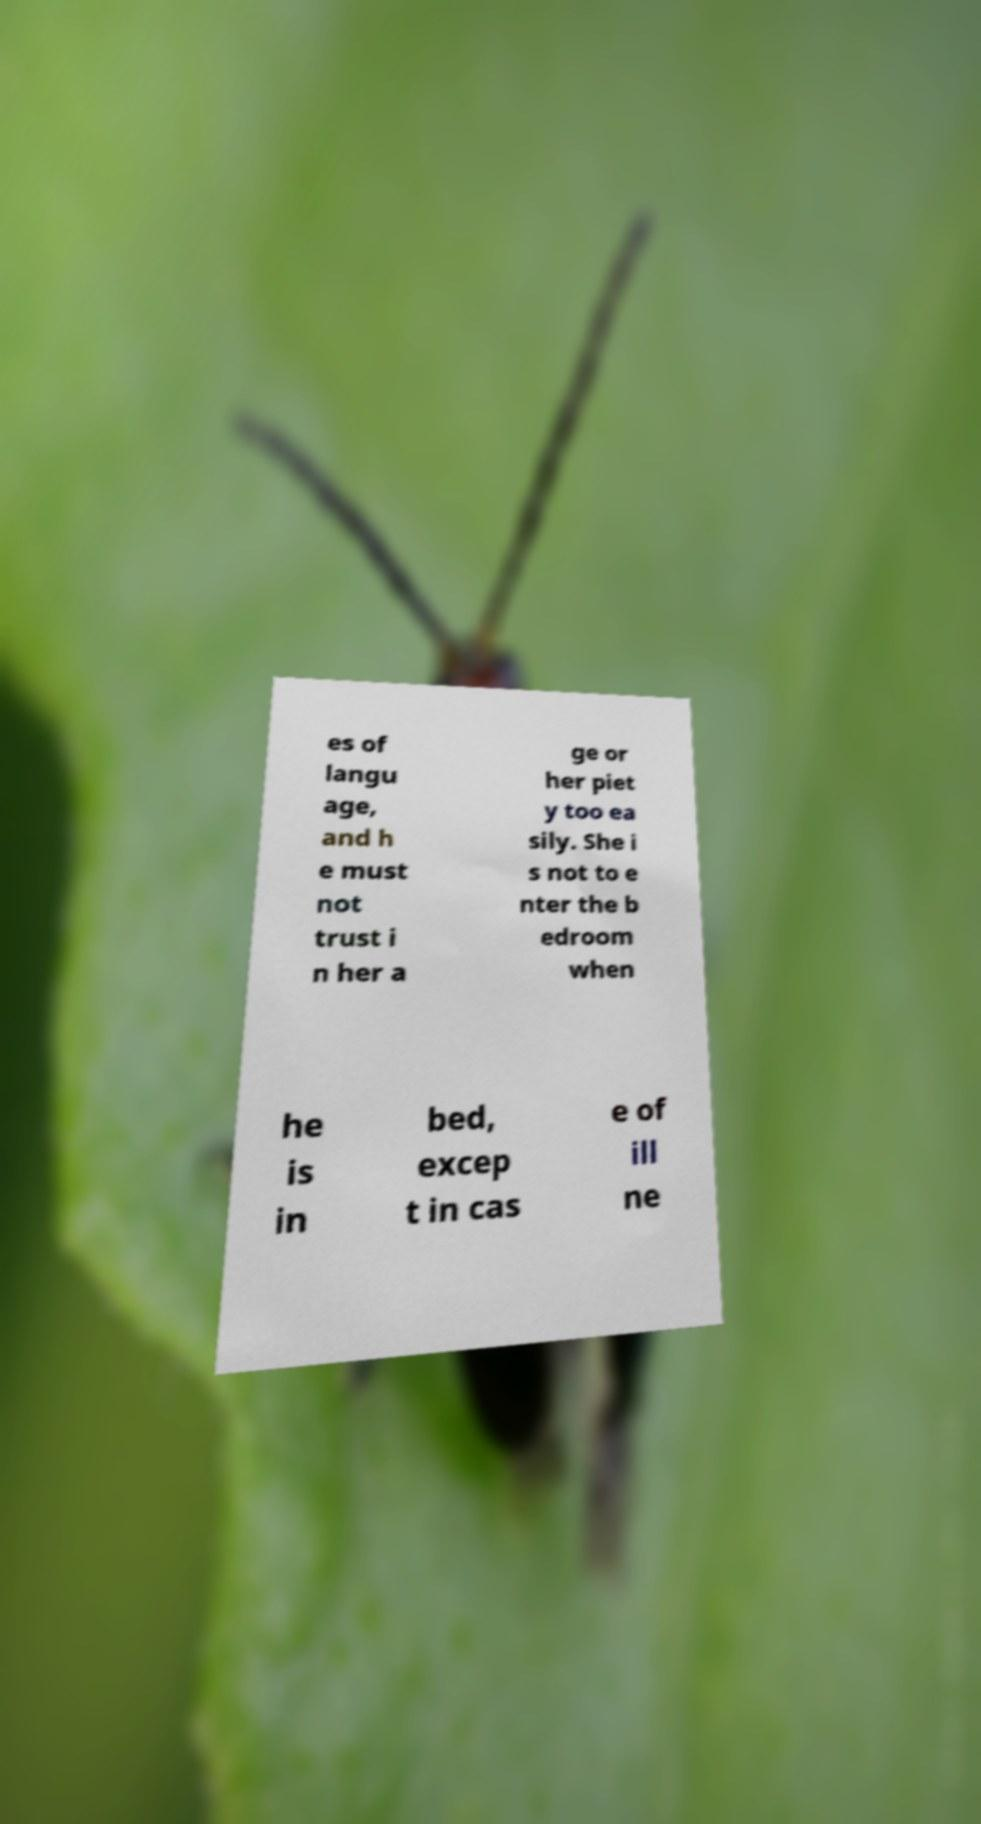There's text embedded in this image that I need extracted. Can you transcribe it verbatim? es of langu age, and h e must not trust i n her a ge or her piet y too ea sily. She i s not to e nter the b edroom when he is in bed, excep t in cas e of ill ne 